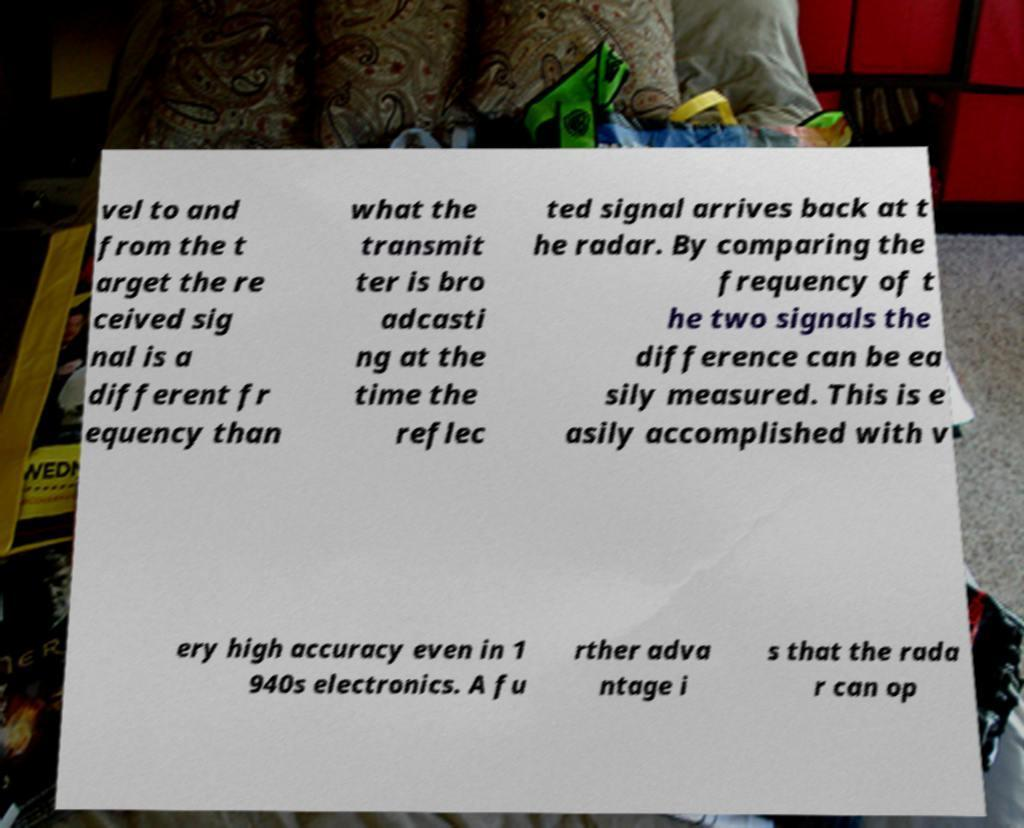There's text embedded in this image that I need extracted. Can you transcribe it verbatim? vel to and from the t arget the re ceived sig nal is a different fr equency than what the transmit ter is bro adcasti ng at the time the reflec ted signal arrives back at t he radar. By comparing the frequency of t he two signals the difference can be ea sily measured. This is e asily accomplished with v ery high accuracy even in 1 940s electronics. A fu rther adva ntage i s that the rada r can op 